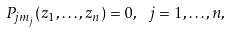Convert formula to latex. <formula><loc_0><loc_0><loc_500><loc_500>P _ { j m _ { j } } ( z _ { 1 } , \dots , z _ { n } ) = 0 , \ j = 1 , \dots , n ,</formula> 